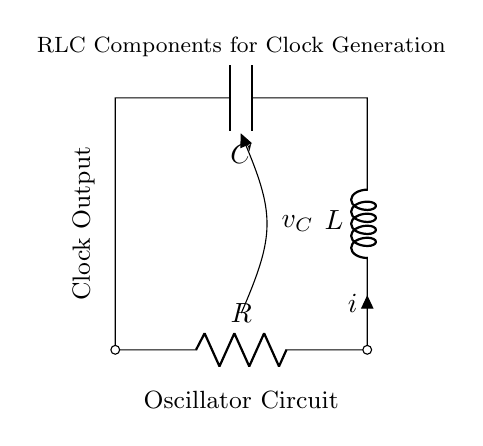What are the components in this circuit? The components visible in the circuit are a resistor, inductor, and capacitor. These are standard components used in RLC circuits, as indicated by their symbols in the diagram.
Answer: Resistor, Inductor, Capacitor What is the output type of this oscillator circuit? The output of this oscillator circuit is a clock signal, which is denoted by the label "Clock Output" in the diagram. This indicates that the circuit is designed to produce a periodic signal.
Answer: Clock Signal What is the function of the resistor in this RLC circuit? The resistor's role in the RLC circuit is to limit current and control the damping of the oscillation. It affects the time period and amplitude of the output signal based on its value.
Answer: Current limiting What is the voltage across the capacitor? The voltage across the capacitor is labeled as v_C in the diagram, which indicates that it is measured between the two terminals of the capacitor.
Answer: v_C How are the components connected in this circuit? The components are connected in a series configuration: first the resistor, then the inductor, and lastly the capacitor in a loop returning to the resistor. This forms a closed circuit necessary for oscillation.
Answer: Series configuration How does the inductor affect the oscillation frequency? The inductor's value, along with the values of the resistor and capacitor, determines the natural frequency of oscillation in the circuit. The interplay between inductance and capacitance allows for the generation of clock pulses.
Answer: Determines frequency What type of circuit is this? This circuit is a type of oscillator circuit that utilizes RLC components, which stands for resistor, inductor, and capacitor, to generate a clock signal.
Answer: Oscillator Circuit 